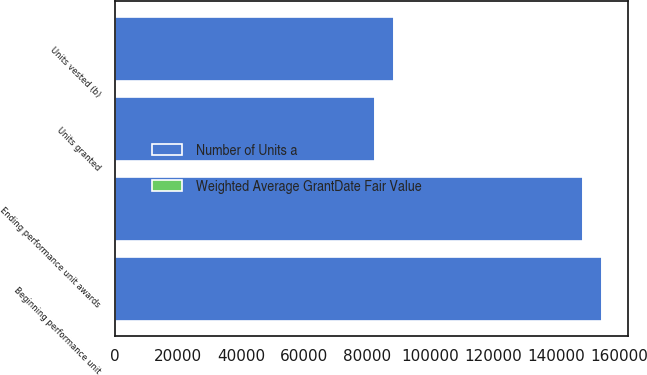<chart> <loc_0><loc_0><loc_500><loc_500><stacked_bar_chart><ecel><fcel>Beginning performance unit<fcel>Units granted<fcel>Units vested (b)<fcel>Ending performance unit awards<nl><fcel>Number of Units a<fcel>154733<fcel>82431<fcel>88617<fcel>148547<nl><fcel>Weighted Average GrantDate Fair Value<fcel>207.88<fcel>222.33<fcel>189.71<fcel>226.74<nl></chart> 